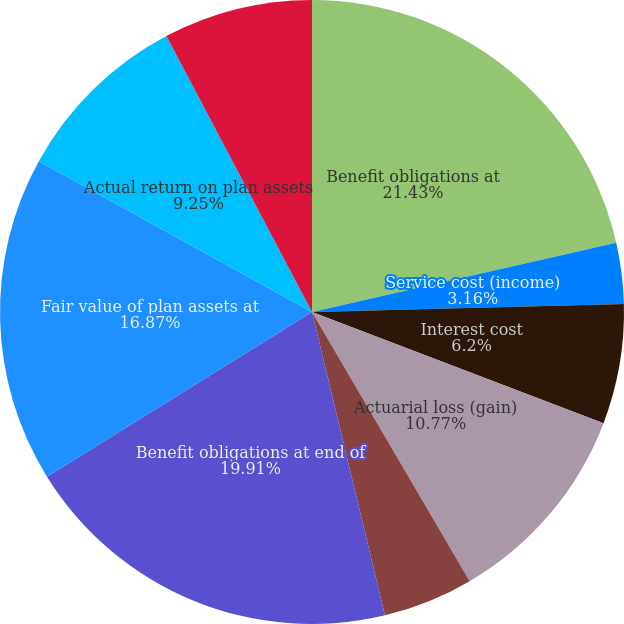Convert chart to OTSL. <chart><loc_0><loc_0><loc_500><loc_500><pie_chart><fcel>Benefit obligations at<fcel>Service cost (income)<fcel>Interest cost<fcel>Actuarial loss (gain)<fcel>Benefit payments<fcel>Benefit obligations at end of<fcel>Fair value of plan assets at<fcel>Actual return on plan assets<fcel>Company contributions<nl><fcel>21.44%<fcel>3.16%<fcel>6.2%<fcel>10.77%<fcel>4.68%<fcel>19.91%<fcel>16.87%<fcel>9.25%<fcel>7.73%<nl></chart> 